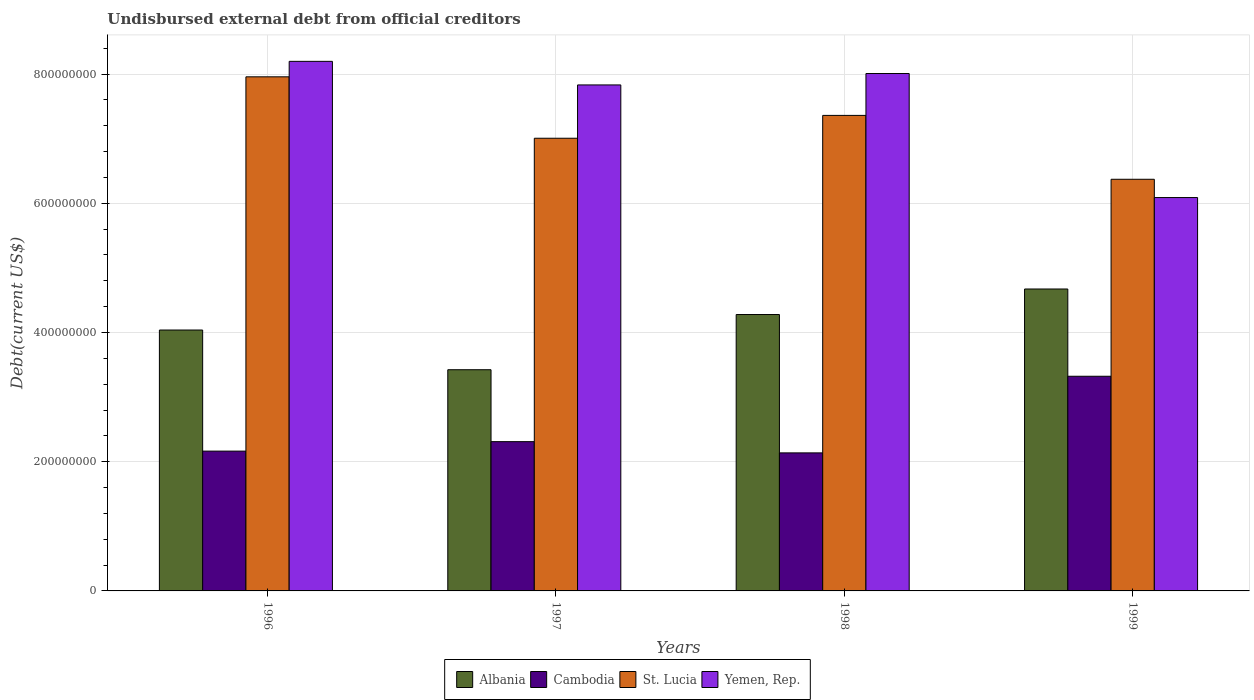How many different coloured bars are there?
Make the answer very short. 4. How many groups of bars are there?
Provide a short and direct response. 4. Are the number of bars per tick equal to the number of legend labels?
Provide a short and direct response. Yes. Are the number of bars on each tick of the X-axis equal?
Ensure brevity in your answer.  Yes. How many bars are there on the 4th tick from the left?
Your answer should be very brief. 4. What is the label of the 3rd group of bars from the left?
Give a very brief answer. 1998. What is the total debt in Albania in 1998?
Provide a short and direct response. 4.28e+08. Across all years, what is the maximum total debt in Yemen, Rep.?
Your answer should be very brief. 8.20e+08. Across all years, what is the minimum total debt in St. Lucia?
Ensure brevity in your answer.  6.37e+08. What is the total total debt in Albania in the graph?
Your response must be concise. 1.64e+09. What is the difference between the total debt in Cambodia in 1998 and that in 1999?
Give a very brief answer. -1.19e+08. What is the difference between the total debt in Albania in 1998 and the total debt in St. Lucia in 1996?
Offer a terse response. -3.68e+08. What is the average total debt in Yemen, Rep. per year?
Provide a succinct answer. 7.53e+08. In the year 1999, what is the difference between the total debt in Albania and total debt in St. Lucia?
Your answer should be compact. -1.70e+08. In how many years, is the total debt in St. Lucia greater than 80000000 US$?
Offer a very short reply. 4. What is the ratio of the total debt in Albania in 1996 to that in 1997?
Your answer should be very brief. 1.18. Is the total debt in St. Lucia in 1998 less than that in 1999?
Offer a very short reply. No. What is the difference between the highest and the second highest total debt in St. Lucia?
Your answer should be very brief. 5.97e+07. What is the difference between the highest and the lowest total debt in Yemen, Rep.?
Provide a succinct answer. 2.11e+08. Is the sum of the total debt in Albania in 1998 and 1999 greater than the maximum total debt in St. Lucia across all years?
Offer a terse response. Yes. Is it the case that in every year, the sum of the total debt in St. Lucia and total debt in Albania is greater than the sum of total debt in Cambodia and total debt in Yemen, Rep.?
Your response must be concise. No. What does the 1st bar from the left in 1998 represents?
Provide a succinct answer. Albania. What does the 4th bar from the right in 1998 represents?
Keep it short and to the point. Albania. Is it the case that in every year, the sum of the total debt in Yemen, Rep. and total debt in Albania is greater than the total debt in St. Lucia?
Your answer should be compact. Yes. How many years are there in the graph?
Give a very brief answer. 4. Are the values on the major ticks of Y-axis written in scientific E-notation?
Provide a succinct answer. No. Does the graph contain any zero values?
Keep it short and to the point. No. Does the graph contain grids?
Your response must be concise. Yes. Where does the legend appear in the graph?
Provide a succinct answer. Bottom center. What is the title of the graph?
Offer a terse response. Undisbursed external debt from official creditors. What is the label or title of the X-axis?
Offer a very short reply. Years. What is the label or title of the Y-axis?
Offer a terse response. Debt(current US$). What is the Debt(current US$) in Albania in 1996?
Keep it short and to the point. 4.04e+08. What is the Debt(current US$) in Cambodia in 1996?
Ensure brevity in your answer.  2.16e+08. What is the Debt(current US$) in St. Lucia in 1996?
Provide a short and direct response. 7.96e+08. What is the Debt(current US$) in Yemen, Rep. in 1996?
Your response must be concise. 8.20e+08. What is the Debt(current US$) in Albania in 1997?
Your answer should be very brief. 3.42e+08. What is the Debt(current US$) in Cambodia in 1997?
Keep it short and to the point. 2.31e+08. What is the Debt(current US$) of St. Lucia in 1997?
Your answer should be very brief. 7.01e+08. What is the Debt(current US$) of Yemen, Rep. in 1997?
Your response must be concise. 7.83e+08. What is the Debt(current US$) in Albania in 1998?
Offer a terse response. 4.28e+08. What is the Debt(current US$) in Cambodia in 1998?
Your response must be concise. 2.14e+08. What is the Debt(current US$) in St. Lucia in 1998?
Your answer should be compact. 7.36e+08. What is the Debt(current US$) in Yemen, Rep. in 1998?
Provide a short and direct response. 8.01e+08. What is the Debt(current US$) in Albania in 1999?
Offer a terse response. 4.67e+08. What is the Debt(current US$) of Cambodia in 1999?
Provide a short and direct response. 3.32e+08. What is the Debt(current US$) of St. Lucia in 1999?
Your answer should be very brief. 6.37e+08. What is the Debt(current US$) in Yemen, Rep. in 1999?
Provide a short and direct response. 6.09e+08. Across all years, what is the maximum Debt(current US$) in Albania?
Give a very brief answer. 4.67e+08. Across all years, what is the maximum Debt(current US$) in Cambodia?
Make the answer very short. 3.32e+08. Across all years, what is the maximum Debt(current US$) of St. Lucia?
Keep it short and to the point. 7.96e+08. Across all years, what is the maximum Debt(current US$) in Yemen, Rep.?
Make the answer very short. 8.20e+08. Across all years, what is the minimum Debt(current US$) in Albania?
Keep it short and to the point. 3.42e+08. Across all years, what is the minimum Debt(current US$) in Cambodia?
Your answer should be compact. 2.14e+08. Across all years, what is the minimum Debt(current US$) of St. Lucia?
Provide a succinct answer. 6.37e+08. Across all years, what is the minimum Debt(current US$) in Yemen, Rep.?
Give a very brief answer. 6.09e+08. What is the total Debt(current US$) in Albania in the graph?
Make the answer very short. 1.64e+09. What is the total Debt(current US$) in Cambodia in the graph?
Make the answer very short. 9.93e+08. What is the total Debt(current US$) in St. Lucia in the graph?
Offer a terse response. 2.87e+09. What is the total Debt(current US$) of Yemen, Rep. in the graph?
Provide a succinct answer. 3.01e+09. What is the difference between the Debt(current US$) of Albania in 1996 and that in 1997?
Offer a terse response. 6.14e+07. What is the difference between the Debt(current US$) in Cambodia in 1996 and that in 1997?
Provide a short and direct response. -1.47e+07. What is the difference between the Debt(current US$) of St. Lucia in 1996 and that in 1997?
Your answer should be very brief. 9.51e+07. What is the difference between the Debt(current US$) in Yemen, Rep. in 1996 and that in 1997?
Offer a terse response. 3.65e+07. What is the difference between the Debt(current US$) in Albania in 1996 and that in 1998?
Offer a terse response. -2.40e+07. What is the difference between the Debt(current US$) of Cambodia in 1996 and that in 1998?
Give a very brief answer. 2.73e+06. What is the difference between the Debt(current US$) of St. Lucia in 1996 and that in 1998?
Provide a succinct answer. 5.97e+07. What is the difference between the Debt(current US$) in Yemen, Rep. in 1996 and that in 1998?
Ensure brevity in your answer.  1.88e+07. What is the difference between the Debt(current US$) in Albania in 1996 and that in 1999?
Keep it short and to the point. -6.35e+07. What is the difference between the Debt(current US$) in Cambodia in 1996 and that in 1999?
Your answer should be compact. -1.16e+08. What is the difference between the Debt(current US$) of St. Lucia in 1996 and that in 1999?
Give a very brief answer. 1.59e+08. What is the difference between the Debt(current US$) of Yemen, Rep. in 1996 and that in 1999?
Offer a very short reply. 2.11e+08. What is the difference between the Debt(current US$) of Albania in 1997 and that in 1998?
Offer a very short reply. -8.54e+07. What is the difference between the Debt(current US$) in Cambodia in 1997 and that in 1998?
Give a very brief answer. 1.74e+07. What is the difference between the Debt(current US$) of St. Lucia in 1997 and that in 1998?
Your answer should be compact. -3.54e+07. What is the difference between the Debt(current US$) in Yemen, Rep. in 1997 and that in 1998?
Offer a terse response. -1.76e+07. What is the difference between the Debt(current US$) in Albania in 1997 and that in 1999?
Offer a terse response. -1.25e+08. What is the difference between the Debt(current US$) in Cambodia in 1997 and that in 1999?
Your response must be concise. -1.01e+08. What is the difference between the Debt(current US$) in St. Lucia in 1997 and that in 1999?
Make the answer very short. 6.35e+07. What is the difference between the Debt(current US$) in Yemen, Rep. in 1997 and that in 1999?
Offer a very short reply. 1.74e+08. What is the difference between the Debt(current US$) of Albania in 1998 and that in 1999?
Your answer should be compact. -3.95e+07. What is the difference between the Debt(current US$) in Cambodia in 1998 and that in 1999?
Your response must be concise. -1.19e+08. What is the difference between the Debt(current US$) of St. Lucia in 1998 and that in 1999?
Make the answer very short. 9.88e+07. What is the difference between the Debt(current US$) of Yemen, Rep. in 1998 and that in 1999?
Make the answer very short. 1.92e+08. What is the difference between the Debt(current US$) in Albania in 1996 and the Debt(current US$) in Cambodia in 1997?
Your response must be concise. 1.73e+08. What is the difference between the Debt(current US$) in Albania in 1996 and the Debt(current US$) in St. Lucia in 1997?
Your response must be concise. -2.97e+08. What is the difference between the Debt(current US$) in Albania in 1996 and the Debt(current US$) in Yemen, Rep. in 1997?
Your response must be concise. -3.79e+08. What is the difference between the Debt(current US$) of Cambodia in 1996 and the Debt(current US$) of St. Lucia in 1997?
Your answer should be compact. -4.84e+08. What is the difference between the Debt(current US$) in Cambodia in 1996 and the Debt(current US$) in Yemen, Rep. in 1997?
Provide a succinct answer. -5.67e+08. What is the difference between the Debt(current US$) in St. Lucia in 1996 and the Debt(current US$) in Yemen, Rep. in 1997?
Ensure brevity in your answer.  1.25e+07. What is the difference between the Debt(current US$) in Albania in 1996 and the Debt(current US$) in Cambodia in 1998?
Offer a terse response. 1.90e+08. What is the difference between the Debt(current US$) of Albania in 1996 and the Debt(current US$) of St. Lucia in 1998?
Ensure brevity in your answer.  -3.32e+08. What is the difference between the Debt(current US$) in Albania in 1996 and the Debt(current US$) in Yemen, Rep. in 1998?
Keep it short and to the point. -3.97e+08. What is the difference between the Debt(current US$) in Cambodia in 1996 and the Debt(current US$) in St. Lucia in 1998?
Your answer should be very brief. -5.20e+08. What is the difference between the Debt(current US$) in Cambodia in 1996 and the Debt(current US$) in Yemen, Rep. in 1998?
Ensure brevity in your answer.  -5.84e+08. What is the difference between the Debt(current US$) of St. Lucia in 1996 and the Debt(current US$) of Yemen, Rep. in 1998?
Your response must be concise. -5.10e+06. What is the difference between the Debt(current US$) of Albania in 1996 and the Debt(current US$) of Cambodia in 1999?
Make the answer very short. 7.15e+07. What is the difference between the Debt(current US$) of Albania in 1996 and the Debt(current US$) of St. Lucia in 1999?
Provide a succinct answer. -2.33e+08. What is the difference between the Debt(current US$) of Albania in 1996 and the Debt(current US$) of Yemen, Rep. in 1999?
Make the answer very short. -2.05e+08. What is the difference between the Debt(current US$) in Cambodia in 1996 and the Debt(current US$) in St. Lucia in 1999?
Your answer should be compact. -4.21e+08. What is the difference between the Debt(current US$) of Cambodia in 1996 and the Debt(current US$) of Yemen, Rep. in 1999?
Give a very brief answer. -3.92e+08. What is the difference between the Debt(current US$) in St. Lucia in 1996 and the Debt(current US$) in Yemen, Rep. in 1999?
Make the answer very short. 1.87e+08. What is the difference between the Debt(current US$) of Albania in 1997 and the Debt(current US$) of Cambodia in 1998?
Provide a short and direct response. 1.29e+08. What is the difference between the Debt(current US$) in Albania in 1997 and the Debt(current US$) in St. Lucia in 1998?
Give a very brief answer. -3.94e+08. What is the difference between the Debt(current US$) in Albania in 1997 and the Debt(current US$) in Yemen, Rep. in 1998?
Your answer should be very brief. -4.58e+08. What is the difference between the Debt(current US$) in Cambodia in 1997 and the Debt(current US$) in St. Lucia in 1998?
Your answer should be compact. -5.05e+08. What is the difference between the Debt(current US$) of Cambodia in 1997 and the Debt(current US$) of Yemen, Rep. in 1998?
Your answer should be compact. -5.70e+08. What is the difference between the Debt(current US$) of St. Lucia in 1997 and the Debt(current US$) of Yemen, Rep. in 1998?
Your answer should be compact. -1.00e+08. What is the difference between the Debt(current US$) in Albania in 1997 and the Debt(current US$) in Cambodia in 1999?
Your response must be concise. 1.01e+07. What is the difference between the Debt(current US$) in Albania in 1997 and the Debt(current US$) in St. Lucia in 1999?
Offer a very short reply. -2.95e+08. What is the difference between the Debt(current US$) in Albania in 1997 and the Debt(current US$) in Yemen, Rep. in 1999?
Provide a succinct answer. -2.66e+08. What is the difference between the Debt(current US$) in Cambodia in 1997 and the Debt(current US$) in St. Lucia in 1999?
Your response must be concise. -4.06e+08. What is the difference between the Debt(current US$) of Cambodia in 1997 and the Debt(current US$) of Yemen, Rep. in 1999?
Ensure brevity in your answer.  -3.78e+08. What is the difference between the Debt(current US$) in St. Lucia in 1997 and the Debt(current US$) in Yemen, Rep. in 1999?
Offer a terse response. 9.18e+07. What is the difference between the Debt(current US$) in Albania in 1998 and the Debt(current US$) in Cambodia in 1999?
Your answer should be very brief. 9.55e+07. What is the difference between the Debt(current US$) in Albania in 1998 and the Debt(current US$) in St. Lucia in 1999?
Ensure brevity in your answer.  -2.09e+08. What is the difference between the Debt(current US$) in Albania in 1998 and the Debt(current US$) in Yemen, Rep. in 1999?
Offer a very short reply. -1.81e+08. What is the difference between the Debt(current US$) of Cambodia in 1998 and the Debt(current US$) of St. Lucia in 1999?
Keep it short and to the point. -4.23e+08. What is the difference between the Debt(current US$) of Cambodia in 1998 and the Debt(current US$) of Yemen, Rep. in 1999?
Your answer should be very brief. -3.95e+08. What is the difference between the Debt(current US$) of St. Lucia in 1998 and the Debt(current US$) of Yemen, Rep. in 1999?
Offer a very short reply. 1.27e+08. What is the average Debt(current US$) in Albania per year?
Offer a terse response. 4.10e+08. What is the average Debt(current US$) in Cambodia per year?
Make the answer very short. 2.48e+08. What is the average Debt(current US$) in St. Lucia per year?
Give a very brief answer. 7.17e+08. What is the average Debt(current US$) in Yemen, Rep. per year?
Your answer should be compact. 7.53e+08. In the year 1996, what is the difference between the Debt(current US$) in Albania and Debt(current US$) in Cambodia?
Offer a very short reply. 1.87e+08. In the year 1996, what is the difference between the Debt(current US$) of Albania and Debt(current US$) of St. Lucia?
Your answer should be very brief. -3.92e+08. In the year 1996, what is the difference between the Debt(current US$) of Albania and Debt(current US$) of Yemen, Rep.?
Provide a short and direct response. -4.16e+08. In the year 1996, what is the difference between the Debt(current US$) in Cambodia and Debt(current US$) in St. Lucia?
Keep it short and to the point. -5.79e+08. In the year 1996, what is the difference between the Debt(current US$) in Cambodia and Debt(current US$) in Yemen, Rep.?
Offer a very short reply. -6.03e+08. In the year 1996, what is the difference between the Debt(current US$) in St. Lucia and Debt(current US$) in Yemen, Rep.?
Make the answer very short. -2.39e+07. In the year 1997, what is the difference between the Debt(current US$) in Albania and Debt(current US$) in Cambodia?
Offer a very short reply. 1.11e+08. In the year 1997, what is the difference between the Debt(current US$) of Albania and Debt(current US$) of St. Lucia?
Offer a terse response. -3.58e+08. In the year 1997, what is the difference between the Debt(current US$) in Albania and Debt(current US$) in Yemen, Rep.?
Provide a succinct answer. -4.41e+08. In the year 1997, what is the difference between the Debt(current US$) of Cambodia and Debt(current US$) of St. Lucia?
Make the answer very short. -4.70e+08. In the year 1997, what is the difference between the Debt(current US$) of Cambodia and Debt(current US$) of Yemen, Rep.?
Provide a short and direct response. -5.52e+08. In the year 1997, what is the difference between the Debt(current US$) in St. Lucia and Debt(current US$) in Yemen, Rep.?
Your response must be concise. -8.25e+07. In the year 1998, what is the difference between the Debt(current US$) of Albania and Debt(current US$) of Cambodia?
Your answer should be compact. 2.14e+08. In the year 1998, what is the difference between the Debt(current US$) in Albania and Debt(current US$) in St. Lucia?
Your answer should be very brief. -3.08e+08. In the year 1998, what is the difference between the Debt(current US$) of Albania and Debt(current US$) of Yemen, Rep.?
Give a very brief answer. -3.73e+08. In the year 1998, what is the difference between the Debt(current US$) of Cambodia and Debt(current US$) of St. Lucia?
Ensure brevity in your answer.  -5.22e+08. In the year 1998, what is the difference between the Debt(current US$) of Cambodia and Debt(current US$) of Yemen, Rep.?
Give a very brief answer. -5.87e+08. In the year 1998, what is the difference between the Debt(current US$) of St. Lucia and Debt(current US$) of Yemen, Rep.?
Make the answer very short. -6.48e+07. In the year 1999, what is the difference between the Debt(current US$) in Albania and Debt(current US$) in Cambodia?
Provide a succinct answer. 1.35e+08. In the year 1999, what is the difference between the Debt(current US$) in Albania and Debt(current US$) in St. Lucia?
Ensure brevity in your answer.  -1.70e+08. In the year 1999, what is the difference between the Debt(current US$) in Albania and Debt(current US$) in Yemen, Rep.?
Your answer should be compact. -1.42e+08. In the year 1999, what is the difference between the Debt(current US$) of Cambodia and Debt(current US$) of St. Lucia?
Keep it short and to the point. -3.05e+08. In the year 1999, what is the difference between the Debt(current US$) in Cambodia and Debt(current US$) in Yemen, Rep.?
Make the answer very short. -2.77e+08. In the year 1999, what is the difference between the Debt(current US$) in St. Lucia and Debt(current US$) in Yemen, Rep.?
Give a very brief answer. 2.83e+07. What is the ratio of the Debt(current US$) in Albania in 1996 to that in 1997?
Give a very brief answer. 1.18. What is the ratio of the Debt(current US$) of Cambodia in 1996 to that in 1997?
Give a very brief answer. 0.94. What is the ratio of the Debt(current US$) of St. Lucia in 1996 to that in 1997?
Make the answer very short. 1.14. What is the ratio of the Debt(current US$) in Yemen, Rep. in 1996 to that in 1997?
Your answer should be very brief. 1.05. What is the ratio of the Debt(current US$) in Albania in 1996 to that in 1998?
Ensure brevity in your answer.  0.94. What is the ratio of the Debt(current US$) of Cambodia in 1996 to that in 1998?
Your answer should be very brief. 1.01. What is the ratio of the Debt(current US$) of St. Lucia in 1996 to that in 1998?
Your answer should be compact. 1.08. What is the ratio of the Debt(current US$) in Yemen, Rep. in 1996 to that in 1998?
Provide a succinct answer. 1.02. What is the ratio of the Debt(current US$) of Albania in 1996 to that in 1999?
Your answer should be very brief. 0.86. What is the ratio of the Debt(current US$) in Cambodia in 1996 to that in 1999?
Give a very brief answer. 0.65. What is the ratio of the Debt(current US$) in St. Lucia in 1996 to that in 1999?
Give a very brief answer. 1.25. What is the ratio of the Debt(current US$) of Yemen, Rep. in 1996 to that in 1999?
Make the answer very short. 1.35. What is the ratio of the Debt(current US$) in Albania in 1997 to that in 1998?
Give a very brief answer. 0.8. What is the ratio of the Debt(current US$) in Cambodia in 1997 to that in 1998?
Provide a short and direct response. 1.08. What is the ratio of the Debt(current US$) of Yemen, Rep. in 1997 to that in 1998?
Your response must be concise. 0.98. What is the ratio of the Debt(current US$) in Albania in 1997 to that in 1999?
Keep it short and to the point. 0.73. What is the ratio of the Debt(current US$) in Cambodia in 1997 to that in 1999?
Ensure brevity in your answer.  0.7. What is the ratio of the Debt(current US$) of St. Lucia in 1997 to that in 1999?
Offer a very short reply. 1.1. What is the ratio of the Debt(current US$) in Yemen, Rep. in 1997 to that in 1999?
Provide a short and direct response. 1.29. What is the ratio of the Debt(current US$) in Albania in 1998 to that in 1999?
Your answer should be very brief. 0.92. What is the ratio of the Debt(current US$) of Cambodia in 1998 to that in 1999?
Offer a terse response. 0.64. What is the ratio of the Debt(current US$) in St. Lucia in 1998 to that in 1999?
Ensure brevity in your answer.  1.16. What is the ratio of the Debt(current US$) of Yemen, Rep. in 1998 to that in 1999?
Offer a very short reply. 1.32. What is the difference between the highest and the second highest Debt(current US$) of Albania?
Provide a succinct answer. 3.95e+07. What is the difference between the highest and the second highest Debt(current US$) in Cambodia?
Your answer should be compact. 1.01e+08. What is the difference between the highest and the second highest Debt(current US$) of St. Lucia?
Your answer should be compact. 5.97e+07. What is the difference between the highest and the second highest Debt(current US$) in Yemen, Rep.?
Provide a short and direct response. 1.88e+07. What is the difference between the highest and the lowest Debt(current US$) of Albania?
Make the answer very short. 1.25e+08. What is the difference between the highest and the lowest Debt(current US$) in Cambodia?
Your answer should be compact. 1.19e+08. What is the difference between the highest and the lowest Debt(current US$) in St. Lucia?
Your answer should be very brief. 1.59e+08. What is the difference between the highest and the lowest Debt(current US$) of Yemen, Rep.?
Offer a very short reply. 2.11e+08. 